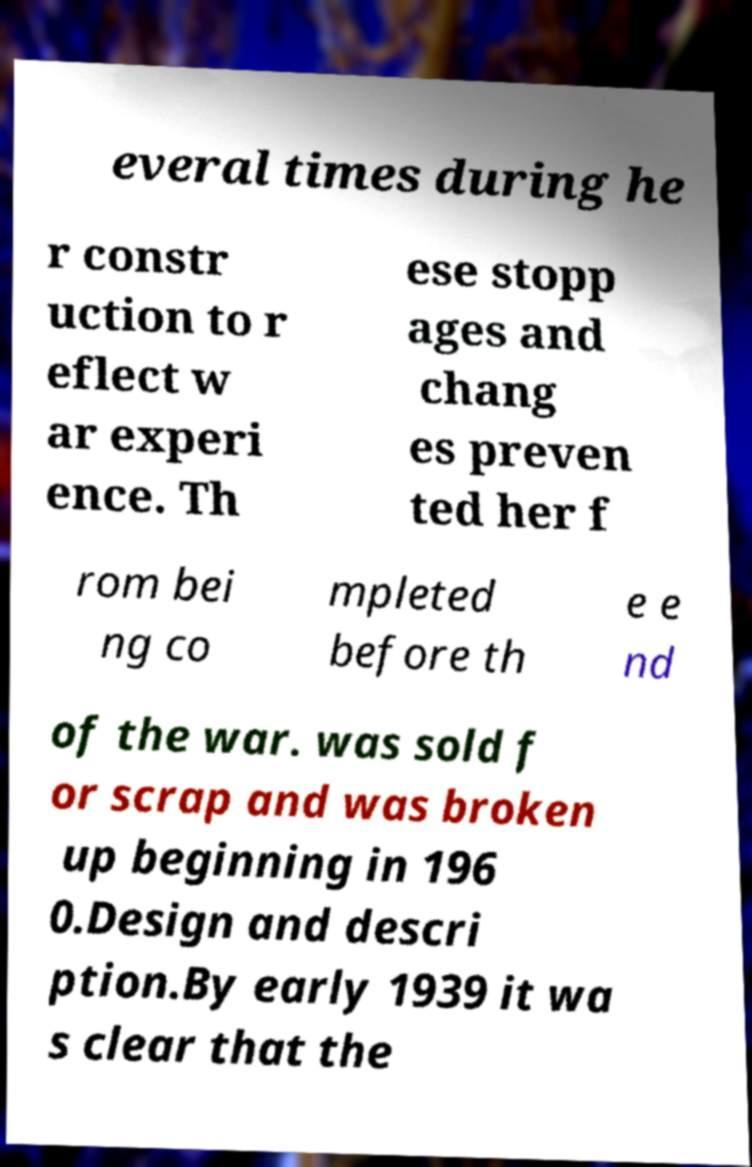Can you accurately transcribe the text from the provided image for me? everal times during he r constr uction to r eflect w ar experi ence. Th ese stopp ages and chang es preven ted her f rom bei ng co mpleted before th e e nd of the war. was sold f or scrap and was broken up beginning in 196 0.Design and descri ption.By early 1939 it wa s clear that the 